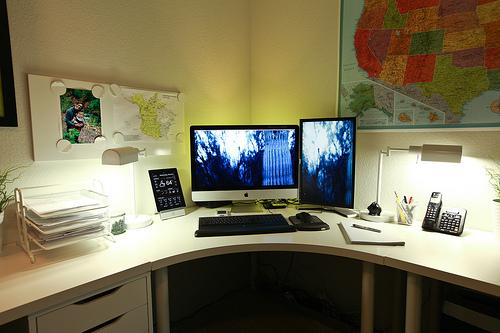Identify the objects found on the desk in the image. Desk top screen, keyboard, mouse, phone, pen stand, note and pen, computer monitors, tablet, and cordless phone. How many computer monitors are present in the image and what are their positions? Two computer monitors are present, one on the left and one on the right. What kind of telephone can be seen on the desk in the image, and what is its color? A cordless phone can be seen on the desk, and it is black in color. Briefly describe the scene in the image with a focus on the office environment. An office scene with a desk containing computer monitors, keyboard, mouse, phone, and tablet, as well as a map hanging on the wall and a lamp turned on. Describe the color and placement of the keyboard and the mouse in the image. The keyboard is black and placed in front of the monitor, while the mouse is also black and placed on the desk. What is the main sentiment evoked by the image, and why? The image evokes a sense of organization and productivity, due to the neat and orderly arrangement of office items on the desk. What type of map can be seen on the wall in the image? A large map of the United States and a small map of Canada. Count the number of light sources present in the image, including lamps and surge protectors. There are three light sources in the image, including two lamps and a red light on the surge protector. Provide a brief analysis of object interactions in the image, focusing on office items. The office items display a sense of interconnectivity and functionality, with the computer monitors, keyboard, mouse, phone, and tablet placed in proximity for efficient and convenient use during work. Name the objects that are stored in the shelf and the table in the image. Papers are arranged in the shelf, and a pen stand, note, pen, and tablet can be found on the table. Is the lamp located on the right of the desk turned off? No, it's not mentioned in the image. What is the country depicted in the large map on the wall? United States Describe the scene in the image in a poetic way. In this quiet office's embrace, objects gather 'round the desk, echoes of ideas fill the space, and a map of dreams hangs steadfast. How many computer monitors can you see in the image? two What are the functions of the mouse and keyboard in relation to the computers? input devices to control and navigate the computer What type of furniture can you see in the image? desk, shelf, and cupboards Describe the desk in the image and list three objects on it. The desk is white and has objects on top such as a keyboard, monitors, and a phone. What is the object in the cup on the desk? pens Is there a red light on the surge protector in the image? Yes Which objects are black colored in the image? keyboard, mouse, phone, mouse pad What is the event taking place in the image? an office scene Which objects are positioned on the left side of the desk? light, computer monitor, keyboard, organizer with papers List all the electronic devices visible in the image. desktop screens, keyboard, mouse, phone, electronic tablet Create a tagline for the electronic devices in the image. Efficiency ignited: indulge in technology that empowers your productivity. Are there any reading materials on the desk? Yes, there are papers in an organizer. What are the positions of the monitors on the desk? one on the left and one on the right Create an informative slogan for the office setup in the image. Elevate your productivity with our dual-screen, organized workspace solution. What is the purpose of the lamp in the image? providing light What color is the phone in the image? black Describe the computer setup on the desk in detail. There is a dual-screen setup on the desk, a black keyboard, a black mouse on a black mouse pad, and an apple computer monitor. Describe the situation using a metaphor. The office is a symphony, where each object plays its part in harmony to create a productive atmosphere. 